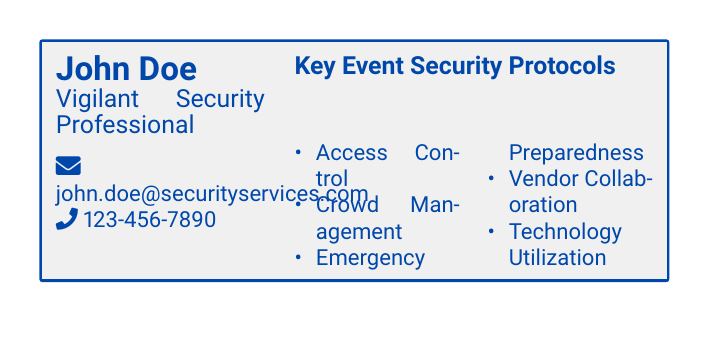What is the professional's name? The document lists the name of the vigilant security professional as John Doe.
Answer: John Doe What is the email address provided? The email address for the security professional is mentioned in the document.
Answer: john.doe@securityservices.com What is the phone number of the security professional? The document contains a phone number associated with John Doe.
Answer: 123-456-7890 What are the key event security protocols mentioned? The document lists specific protocols under "Key Event Security Protocols."
Answer: Access Control, Crowd Management, Emergency Preparedness, Vendor Collaboration, Technology Utilization How many key security protocols are listed? There are multiple protocols categorized in the document, which can be counted.
Answer: 5 What is the color theme used in the business card? The document features a specific color called "securityblue" for the text and borders.
Answer: Security Blue Which tool is used to display the information in the document? The document is created using a specific document creation tool as indicated by the syntax.
Answer: LaTeX What is the layout of the document? The document's layout is characterized by a specific orientation and structure as indicated by the code.
Answer: Landscape 